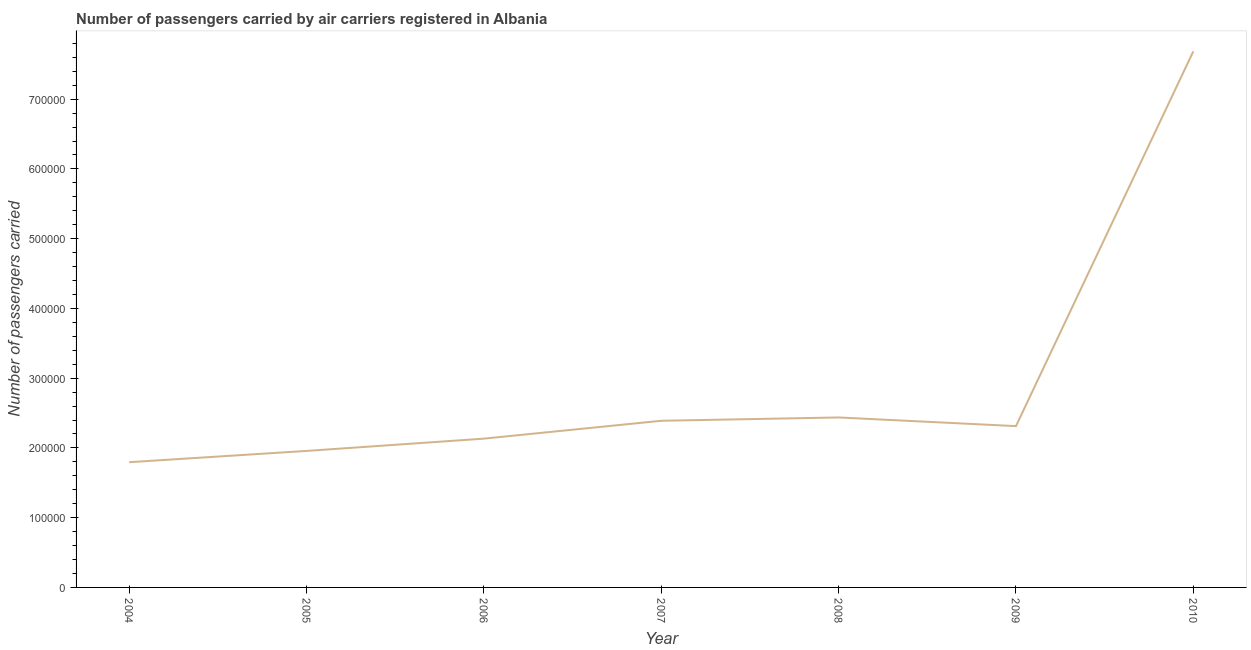What is the number of passengers carried in 2004?
Your answer should be very brief. 1.80e+05. Across all years, what is the maximum number of passengers carried?
Your answer should be compact. 7.69e+05. Across all years, what is the minimum number of passengers carried?
Ensure brevity in your answer.  1.80e+05. In which year was the number of passengers carried maximum?
Make the answer very short. 2010. What is the sum of the number of passengers carried?
Your response must be concise. 2.07e+06. What is the difference between the number of passengers carried in 2006 and 2009?
Provide a succinct answer. -1.79e+04. What is the average number of passengers carried per year?
Your response must be concise. 2.96e+05. What is the median number of passengers carried?
Ensure brevity in your answer.  2.31e+05. What is the ratio of the number of passengers carried in 2008 to that in 2010?
Your answer should be very brief. 0.32. Is the number of passengers carried in 2008 less than that in 2010?
Offer a very short reply. Yes. What is the difference between the highest and the second highest number of passengers carried?
Your response must be concise. 5.25e+05. What is the difference between the highest and the lowest number of passengers carried?
Provide a succinct answer. 5.89e+05. How many lines are there?
Provide a succinct answer. 1. What is the difference between two consecutive major ticks on the Y-axis?
Give a very brief answer. 1.00e+05. Does the graph contain any zero values?
Your response must be concise. No. Does the graph contain grids?
Provide a succinct answer. No. What is the title of the graph?
Your response must be concise. Number of passengers carried by air carriers registered in Albania. What is the label or title of the Y-axis?
Provide a short and direct response. Number of passengers carried. What is the Number of passengers carried of 2004?
Provide a short and direct response. 1.80e+05. What is the Number of passengers carried of 2005?
Offer a terse response. 1.96e+05. What is the Number of passengers carried of 2006?
Provide a succinct answer. 2.13e+05. What is the Number of passengers carried in 2007?
Your response must be concise. 2.39e+05. What is the Number of passengers carried of 2008?
Your answer should be very brief. 2.44e+05. What is the Number of passengers carried of 2009?
Provide a short and direct response. 2.31e+05. What is the Number of passengers carried in 2010?
Keep it short and to the point. 7.69e+05. What is the difference between the Number of passengers carried in 2004 and 2005?
Provide a succinct answer. -1.62e+04. What is the difference between the Number of passengers carried in 2004 and 2006?
Make the answer very short. -3.38e+04. What is the difference between the Number of passengers carried in 2004 and 2007?
Give a very brief answer. -5.94e+04. What is the difference between the Number of passengers carried in 2004 and 2008?
Make the answer very short. -6.41e+04. What is the difference between the Number of passengers carried in 2004 and 2009?
Give a very brief answer. -5.17e+04. What is the difference between the Number of passengers carried in 2004 and 2010?
Give a very brief answer. -5.89e+05. What is the difference between the Number of passengers carried in 2005 and 2006?
Your answer should be very brief. -1.76e+04. What is the difference between the Number of passengers carried in 2005 and 2007?
Make the answer very short. -4.32e+04. What is the difference between the Number of passengers carried in 2005 and 2008?
Your answer should be very brief. -4.80e+04. What is the difference between the Number of passengers carried in 2005 and 2009?
Your response must be concise. -3.56e+04. What is the difference between the Number of passengers carried in 2005 and 2010?
Offer a very short reply. -5.73e+05. What is the difference between the Number of passengers carried in 2006 and 2007?
Provide a succinct answer. -2.56e+04. What is the difference between the Number of passengers carried in 2006 and 2008?
Ensure brevity in your answer.  -3.04e+04. What is the difference between the Number of passengers carried in 2006 and 2009?
Give a very brief answer. -1.79e+04. What is the difference between the Number of passengers carried in 2006 and 2010?
Give a very brief answer. -5.55e+05. What is the difference between the Number of passengers carried in 2007 and 2008?
Offer a very short reply. -4778. What is the difference between the Number of passengers carried in 2007 and 2009?
Your answer should be very brief. 7650. What is the difference between the Number of passengers carried in 2007 and 2010?
Provide a short and direct response. -5.30e+05. What is the difference between the Number of passengers carried in 2008 and 2009?
Make the answer very short. 1.24e+04. What is the difference between the Number of passengers carried in 2008 and 2010?
Provide a short and direct response. -5.25e+05. What is the difference between the Number of passengers carried in 2009 and 2010?
Provide a succinct answer. -5.37e+05. What is the ratio of the Number of passengers carried in 2004 to that in 2005?
Give a very brief answer. 0.92. What is the ratio of the Number of passengers carried in 2004 to that in 2006?
Provide a succinct answer. 0.84. What is the ratio of the Number of passengers carried in 2004 to that in 2007?
Make the answer very short. 0.75. What is the ratio of the Number of passengers carried in 2004 to that in 2008?
Your answer should be very brief. 0.74. What is the ratio of the Number of passengers carried in 2004 to that in 2009?
Offer a very short reply. 0.78. What is the ratio of the Number of passengers carried in 2004 to that in 2010?
Provide a succinct answer. 0.23. What is the ratio of the Number of passengers carried in 2005 to that in 2006?
Your answer should be compact. 0.92. What is the ratio of the Number of passengers carried in 2005 to that in 2007?
Offer a terse response. 0.82. What is the ratio of the Number of passengers carried in 2005 to that in 2008?
Give a very brief answer. 0.8. What is the ratio of the Number of passengers carried in 2005 to that in 2009?
Your answer should be compact. 0.85. What is the ratio of the Number of passengers carried in 2005 to that in 2010?
Offer a very short reply. 0.26. What is the ratio of the Number of passengers carried in 2006 to that in 2007?
Ensure brevity in your answer.  0.89. What is the ratio of the Number of passengers carried in 2006 to that in 2008?
Keep it short and to the point. 0.88. What is the ratio of the Number of passengers carried in 2006 to that in 2009?
Your response must be concise. 0.92. What is the ratio of the Number of passengers carried in 2006 to that in 2010?
Offer a terse response. 0.28. What is the ratio of the Number of passengers carried in 2007 to that in 2008?
Offer a very short reply. 0.98. What is the ratio of the Number of passengers carried in 2007 to that in 2009?
Offer a very short reply. 1.03. What is the ratio of the Number of passengers carried in 2007 to that in 2010?
Offer a terse response. 0.31. What is the ratio of the Number of passengers carried in 2008 to that in 2009?
Keep it short and to the point. 1.05. What is the ratio of the Number of passengers carried in 2008 to that in 2010?
Ensure brevity in your answer.  0.32. What is the ratio of the Number of passengers carried in 2009 to that in 2010?
Offer a very short reply. 0.3. 